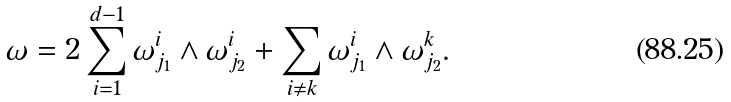<formula> <loc_0><loc_0><loc_500><loc_500>\omega = 2 \sum _ { i = 1 } ^ { d - 1 } \omega ^ { i } _ { j _ { 1 } } \wedge \omega ^ { i } _ { j _ { 2 } } + \sum _ { i \neq k } \omega ^ { i } _ { j _ { 1 } } \wedge \omega ^ { k } _ { j _ { 2 } } .</formula> 